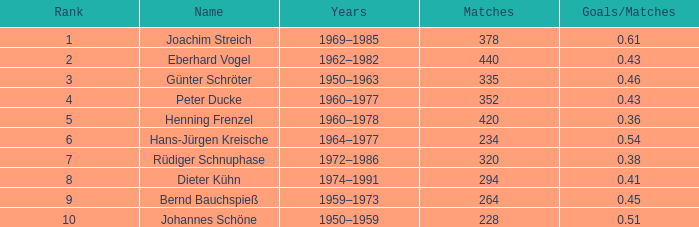What average goals have matches less than 228? None. 